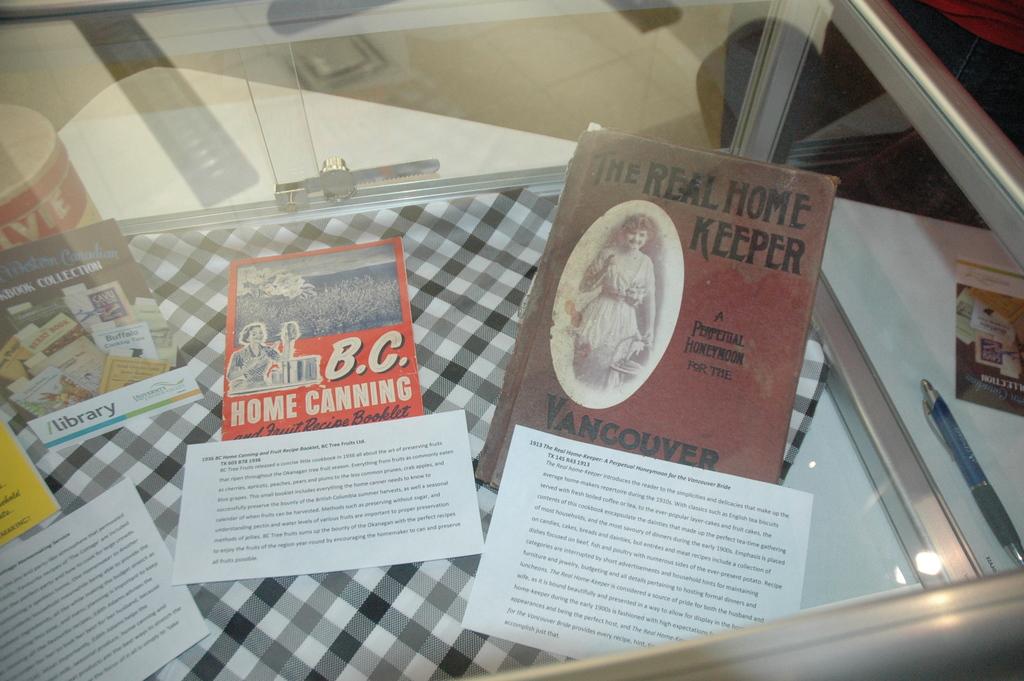What is advertised in red on the left?
Make the answer very short. Home canning. 